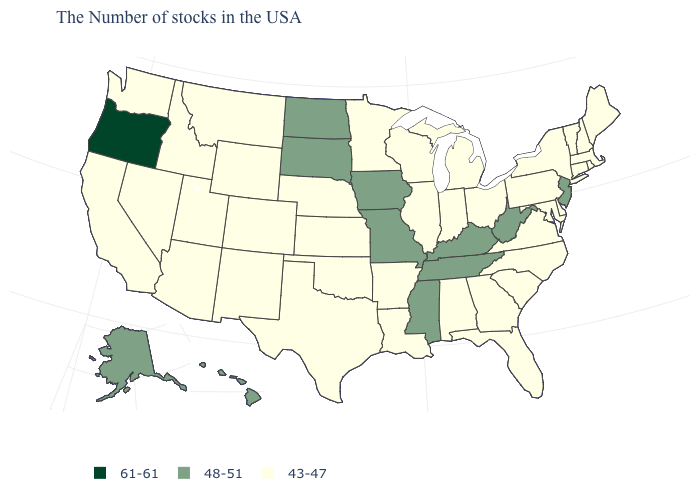What is the value of Wyoming?
Quick response, please. 43-47. Which states have the lowest value in the USA?
Write a very short answer. Maine, Massachusetts, Rhode Island, New Hampshire, Vermont, Connecticut, New York, Delaware, Maryland, Pennsylvania, Virginia, North Carolina, South Carolina, Ohio, Florida, Georgia, Michigan, Indiana, Alabama, Wisconsin, Illinois, Louisiana, Arkansas, Minnesota, Kansas, Nebraska, Oklahoma, Texas, Wyoming, Colorado, New Mexico, Utah, Montana, Arizona, Idaho, Nevada, California, Washington. Name the states that have a value in the range 43-47?
Write a very short answer. Maine, Massachusetts, Rhode Island, New Hampshire, Vermont, Connecticut, New York, Delaware, Maryland, Pennsylvania, Virginia, North Carolina, South Carolina, Ohio, Florida, Georgia, Michigan, Indiana, Alabama, Wisconsin, Illinois, Louisiana, Arkansas, Minnesota, Kansas, Nebraska, Oklahoma, Texas, Wyoming, Colorado, New Mexico, Utah, Montana, Arizona, Idaho, Nevada, California, Washington. Which states have the lowest value in the West?
Keep it brief. Wyoming, Colorado, New Mexico, Utah, Montana, Arizona, Idaho, Nevada, California, Washington. Which states have the lowest value in the USA?
Quick response, please. Maine, Massachusetts, Rhode Island, New Hampshire, Vermont, Connecticut, New York, Delaware, Maryland, Pennsylvania, Virginia, North Carolina, South Carolina, Ohio, Florida, Georgia, Michigan, Indiana, Alabama, Wisconsin, Illinois, Louisiana, Arkansas, Minnesota, Kansas, Nebraska, Oklahoma, Texas, Wyoming, Colorado, New Mexico, Utah, Montana, Arizona, Idaho, Nevada, California, Washington. Name the states that have a value in the range 43-47?
Keep it brief. Maine, Massachusetts, Rhode Island, New Hampshire, Vermont, Connecticut, New York, Delaware, Maryland, Pennsylvania, Virginia, North Carolina, South Carolina, Ohio, Florida, Georgia, Michigan, Indiana, Alabama, Wisconsin, Illinois, Louisiana, Arkansas, Minnesota, Kansas, Nebraska, Oklahoma, Texas, Wyoming, Colorado, New Mexico, Utah, Montana, Arizona, Idaho, Nevada, California, Washington. What is the highest value in the USA?
Quick response, please. 61-61. What is the highest value in the Northeast ?
Be succinct. 48-51. Does Rhode Island have a higher value than Michigan?
Short answer required. No. Does Oregon have the highest value in the USA?
Quick response, please. Yes. Is the legend a continuous bar?
Write a very short answer. No. Which states have the lowest value in the MidWest?
Quick response, please. Ohio, Michigan, Indiana, Wisconsin, Illinois, Minnesota, Kansas, Nebraska. Does Alaska have the lowest value in the West?
Quick response, please. No. Name the states that have a value in the range 48-51?
Quick response, please. New Jersey, West Virginia, Kentucky, Tennessee, Mississippi, Missouri, Iowa, South Dakota, North Dakota, Alaska, Hawaii. Does the map have missing data?
Quick response, please. No. 